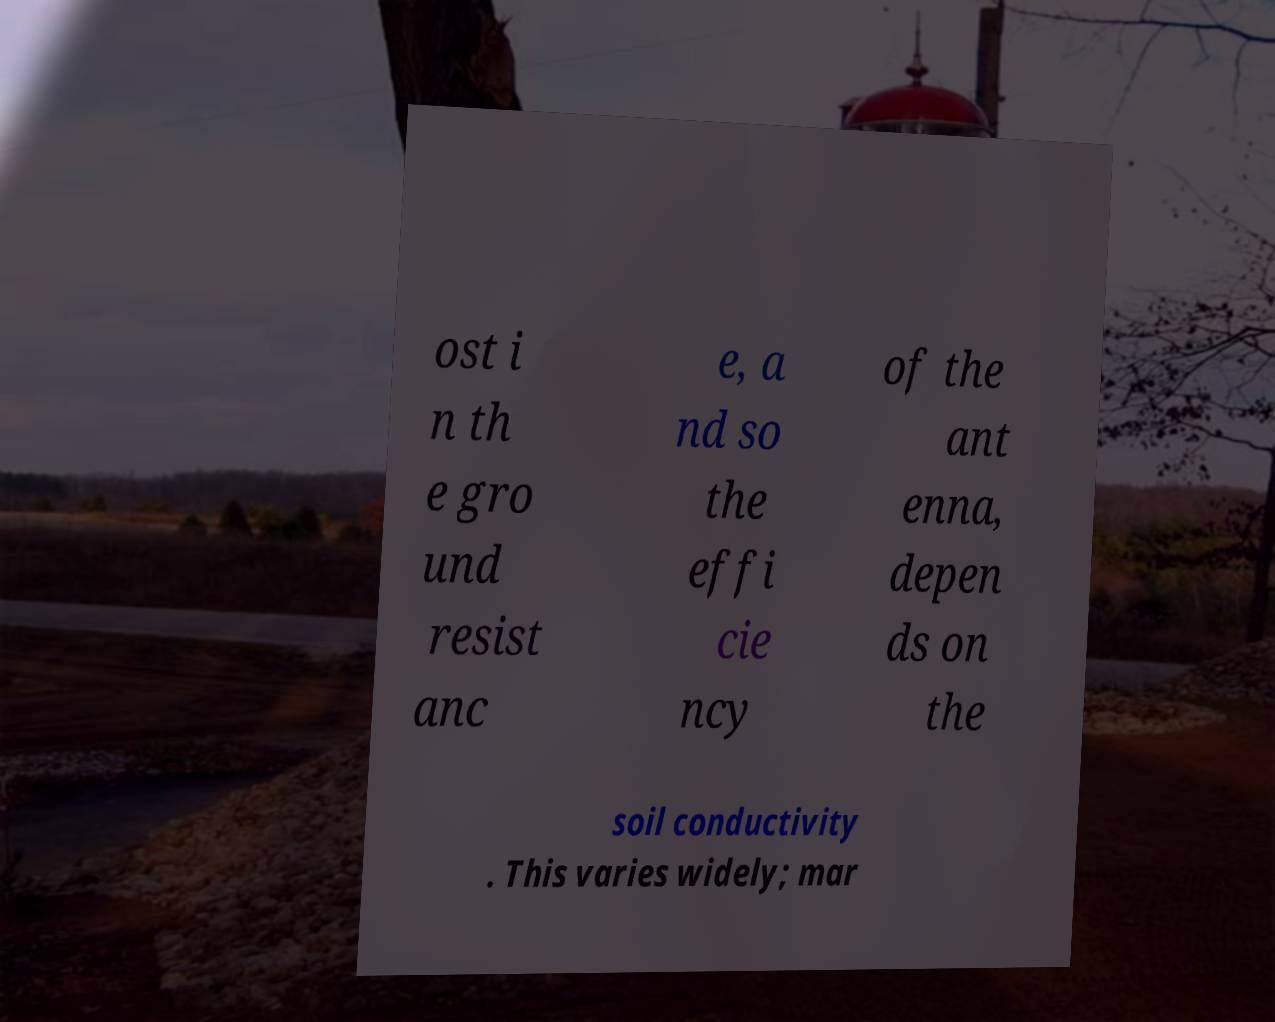Please read and relay the text visible in this image. What does it say? ost i n th e gro und resist anc e, a nd so the effi cie ncy of the ant enna, depen ds on the soil conductivity . This varies widely; mar 